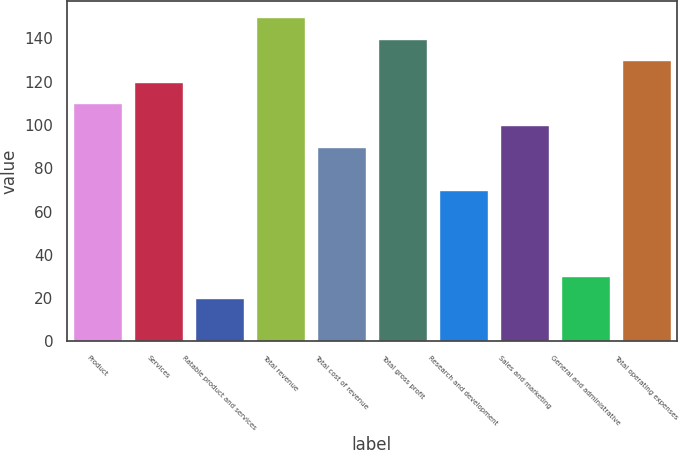Convert chart. <chart><loc_0><loc_0><loc_500><loc_500><bar_chart><fcel>Product<fcel>Services<fcel>Ratable product and services<fcel>Total revenue<fcel>Total cost of revenue<fcel>Total gross profit<fcel>Research and development<fcel>Sales and marketing<fcel>General and administrative<fcel>Total operating expenses<nl><fcel>109.99<fcel>119.98<fcel>20.08<fcel>149.95<fcel>90.01<fcel>139.96<fcel>70.03<fcel>100<fcel>30.07<fcel>129.97<nl></chart> 